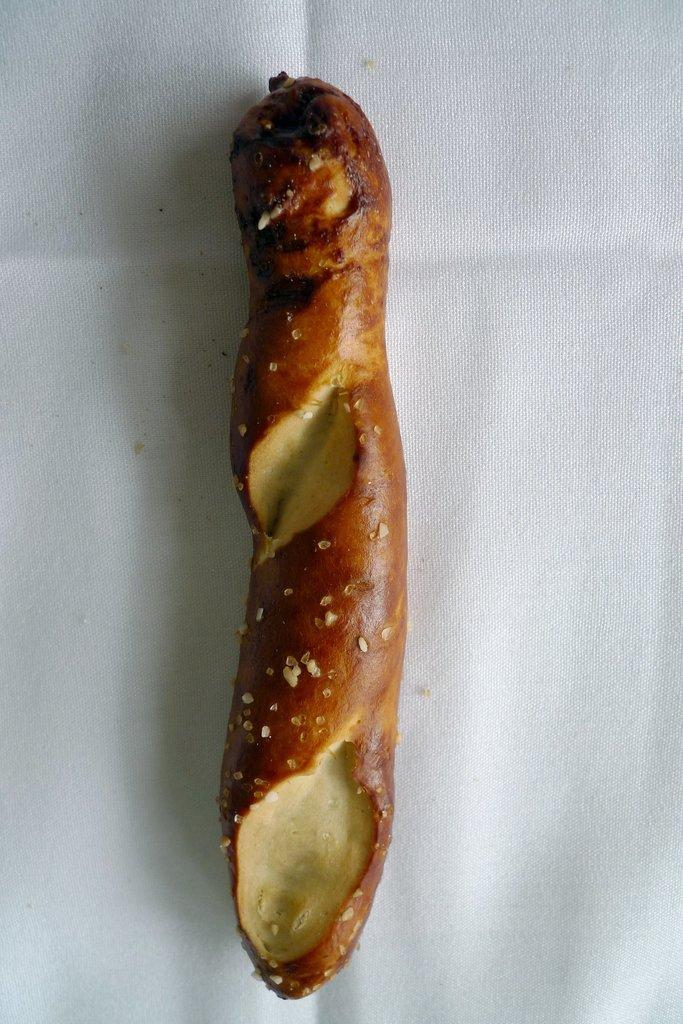What is present in the image? There is food in the image. What can be observed about the background of the image? The background of the image is white. Can you see a snake slithering in the image? There is no snake present in the image. Is there a chicken or rabbit visible in the image? There is no chicken or rabbit visible in the image. 